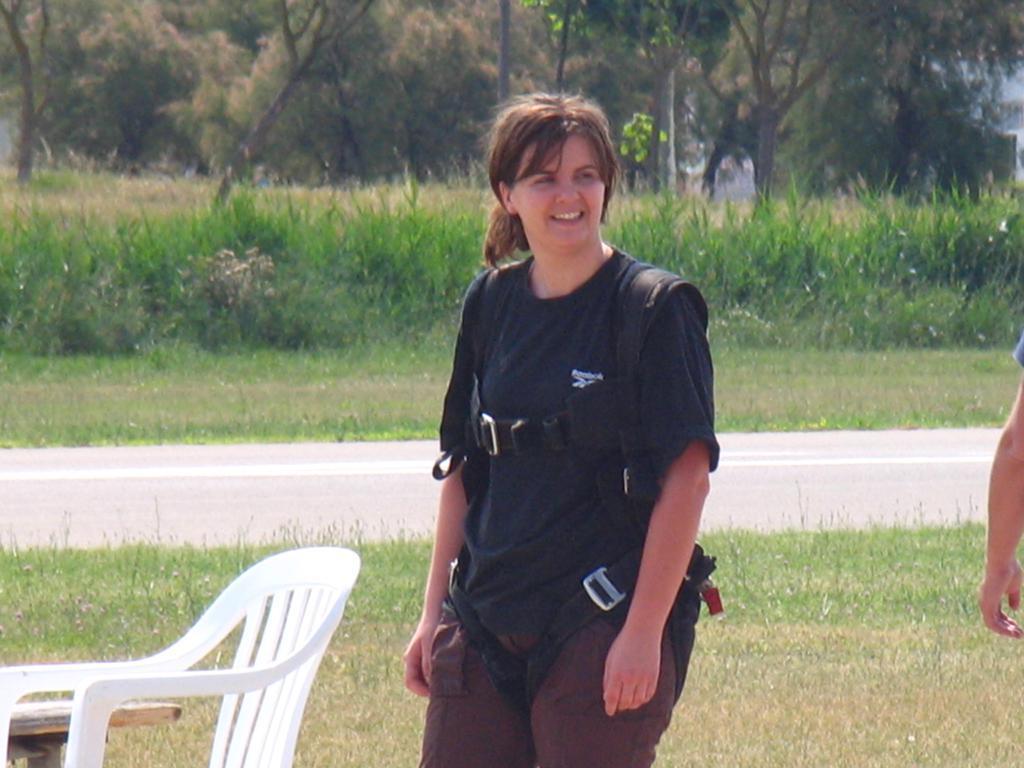In one or two sentences, can you explain what this image depicts? In this image I can see woman standing there is a chair and a table. At the back side we can see a grass and a trees. 